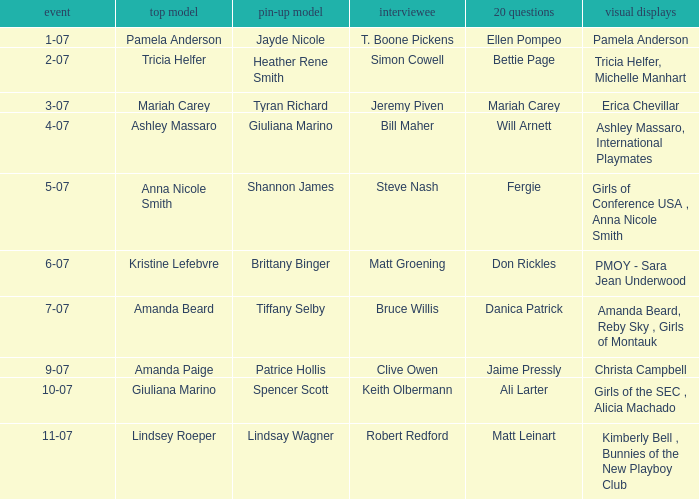Could you parse the entire table as a dict? {'header': ['event', 'top model', 'pin-up model', 'interviewee', '20 questions', 'visual displays'], 'rows': [['1-07', 'Pamela Anderson', 'Jayde Nicole', 'T. Boone Pickens', 'Ellen Pompeo', 'Pamela Anderson'], ['2-07', 'Tricia Helfer', 'Heather Rene Smith', 'Simon Cowell', 'Bettie Page', 'Tricia Helfer, Michelle Manhart'], ['3-07', 'Mariah Carey', 'Tyran Richard', 'Jeremy Piven', 'Mariah Carey', 'Erica Chevillar'], ['4-07', 'Ashley Massaro', 'Giuliana Marino', 'Bill Maher', 'Will Arnett', 'Ashley Massaro, International Playmates'], ['5-07', 'Anna Nicole Smith', 'Shannon James', 'Steve Nash', 'Fergie', 'Girls of Conference USA , Anna Nicole Smith'], ['6-07', 'Kristine Lefebvre', 'Brittany Binger', 'Matt Groening', 'Don Rickles', 'PMOY - Sara Jean Underwood'], ['7-07', 'Amanda Beard', 'Tiffany Selby', 'Bruce Willis', 'Danica Patrick', 'Amanda Beard, Reby Sky , Girls of Montauk'], ['9-07', 'Amanda Paige', 'Patrice Hollis', 'Clive Owen', 'Jaime Pressly', 'Christa Campbell'], ['10-07', 'Giuliana Marino', 'Spencer Scott', 'Keith Olbermann', 'Ali Larter', 'Girls of the SEC , Alicia Machado'], ['11-07', 'Lindsey Roeper', 'Lindsay Wagner', 'Robert Redford', 'Matt Leinart', 'Kimberly Bell , Bunnies of the New Playboy Club']]} Who was the centerfold model in the issue where Fergie answered the "20 questions"? Shannon James. 